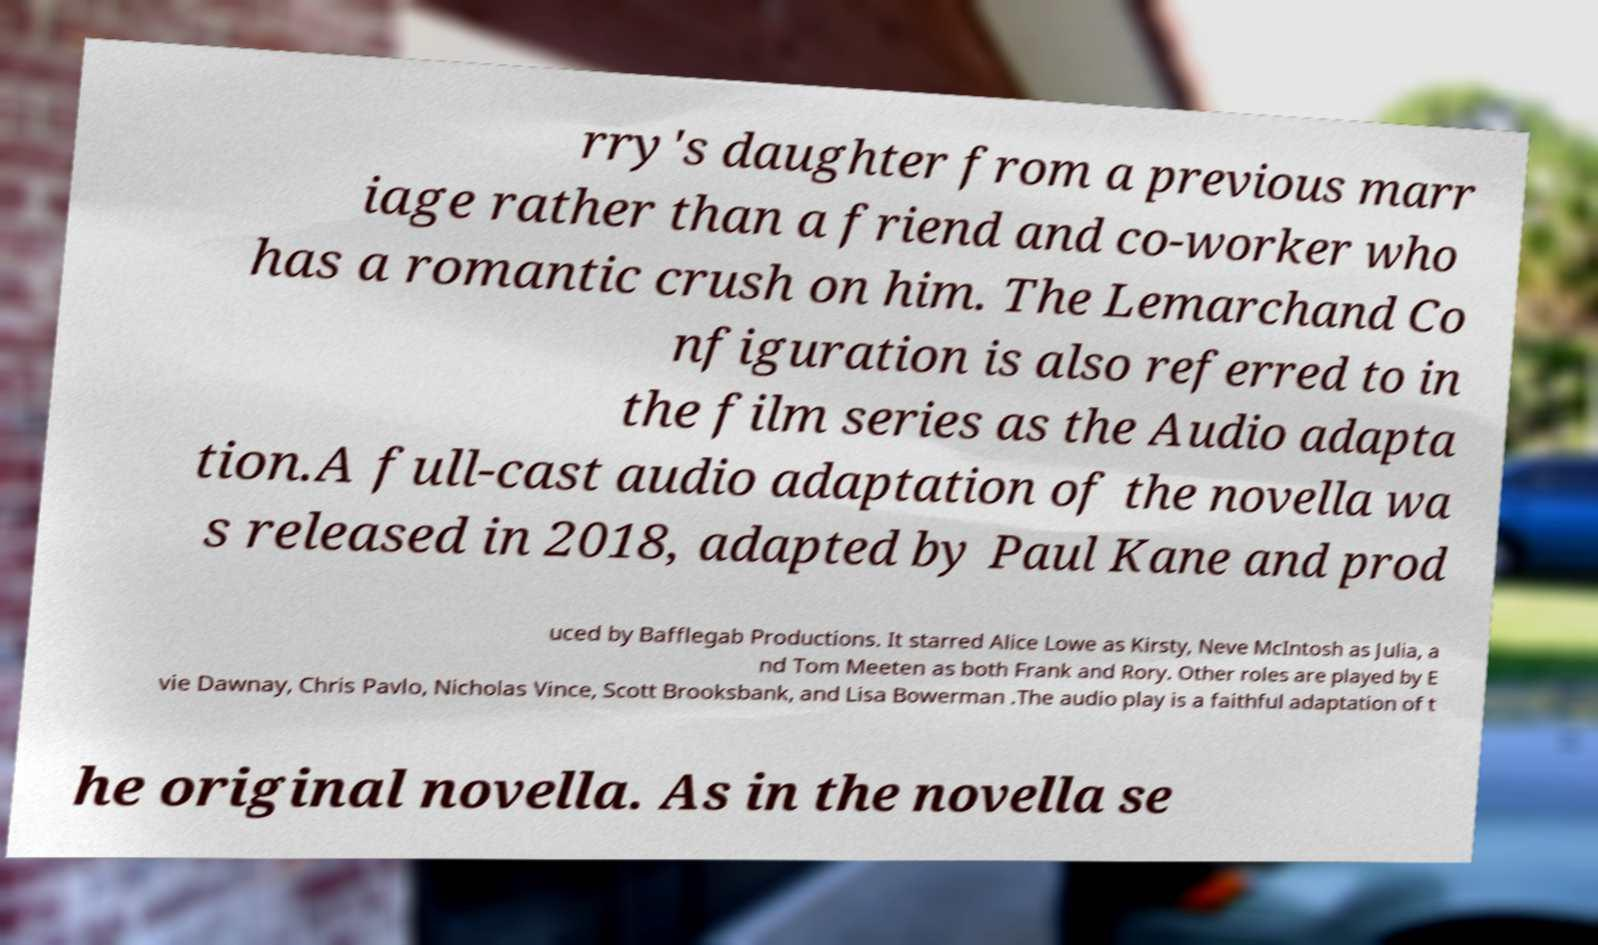For documentation purposes, I need the text within this image transcribed. Could you provide that? rry's daughter from a previous marr iage rather than a friend and co-worker who has a romantic crush on him. The Lemarchand Co nfiguration is also referred to in the film series as the Audio adapta tion.A full-cast audio adaptation of the novella wa s released in 2018, adapted by Paul Kane and prod uced by Bafflegab Productions. It starred Alice Lowe as Kirsty, Neve McIntosh as Julia, a nd Tom Meeten as both Frank and Rory. Other roles are played by E vie Dawnay, Chris Pavlo, Nicholas Vince, Scott Brooksbank, and Lisa Bowerman .The audio play is a faithful adaptation of t he original novella. As in the novella se 